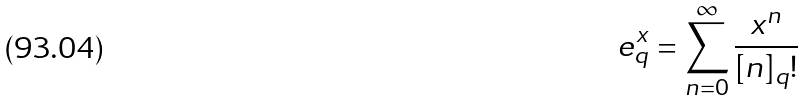Convert formula to latex. <formula><loc_0><loc_0><loc_500><loc_500>e _ { q } ^ { x } = \sum _ { n = 0 } ^ { \infty } \frac { x ^ { n } } { [ n ] _ { q } ! }</formula> 